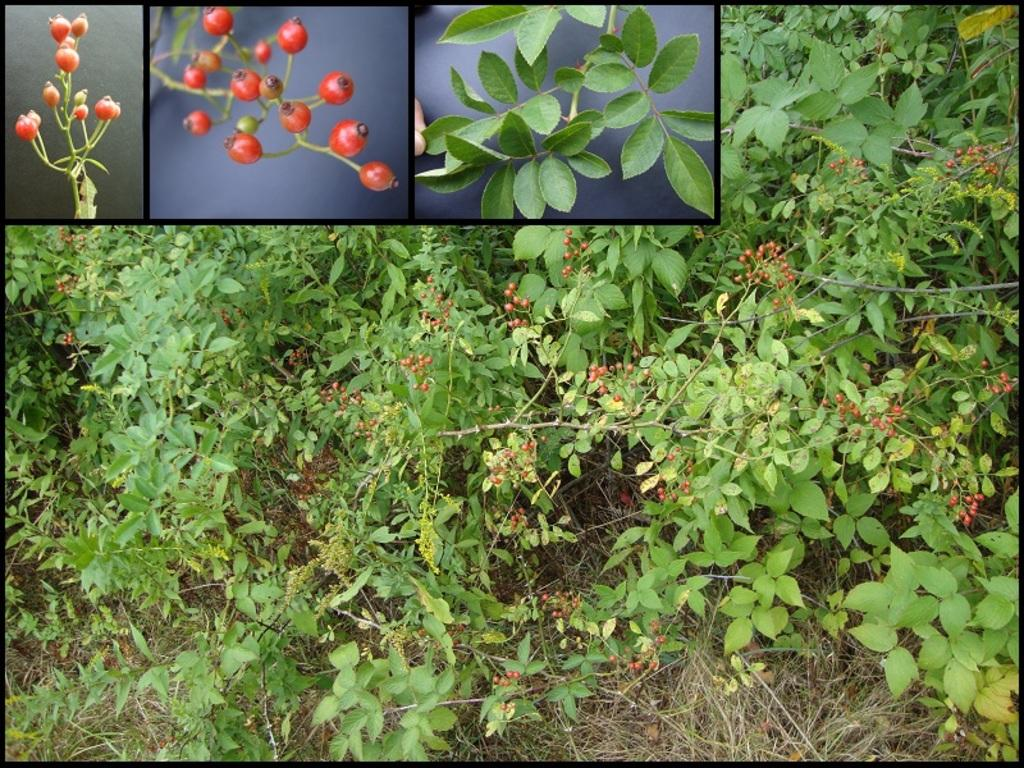What type of fruit can be seen in the image? There are berries in the image. What else is present in the image besides the berries? There are leaves and plants visible in the image. What type of vegetation is present in the image? There is grass visible in the image. How many sisters are present in the image? There are no sisters present in the image; it features berries, leaves, plants, and grass. 